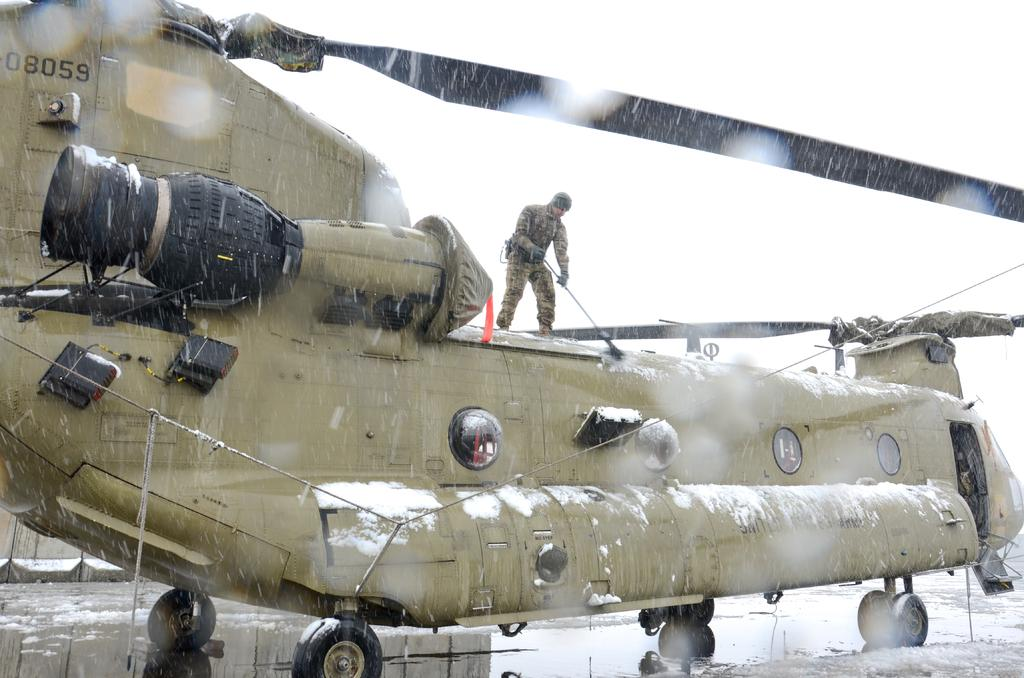<image>
Write a terse but informative summary of the picture. the number 08059 is on the brown helicopter 